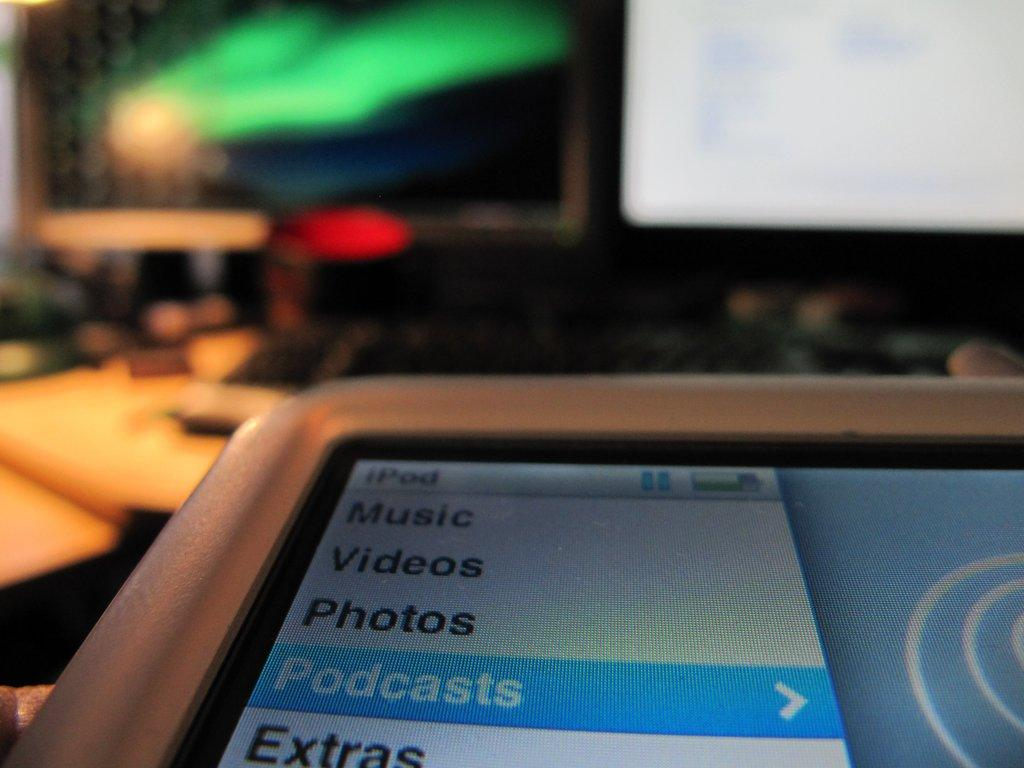<image>
Relay a brief, clear account of the picture shown. a device screen is showing music, videos, photos and a few other categories 